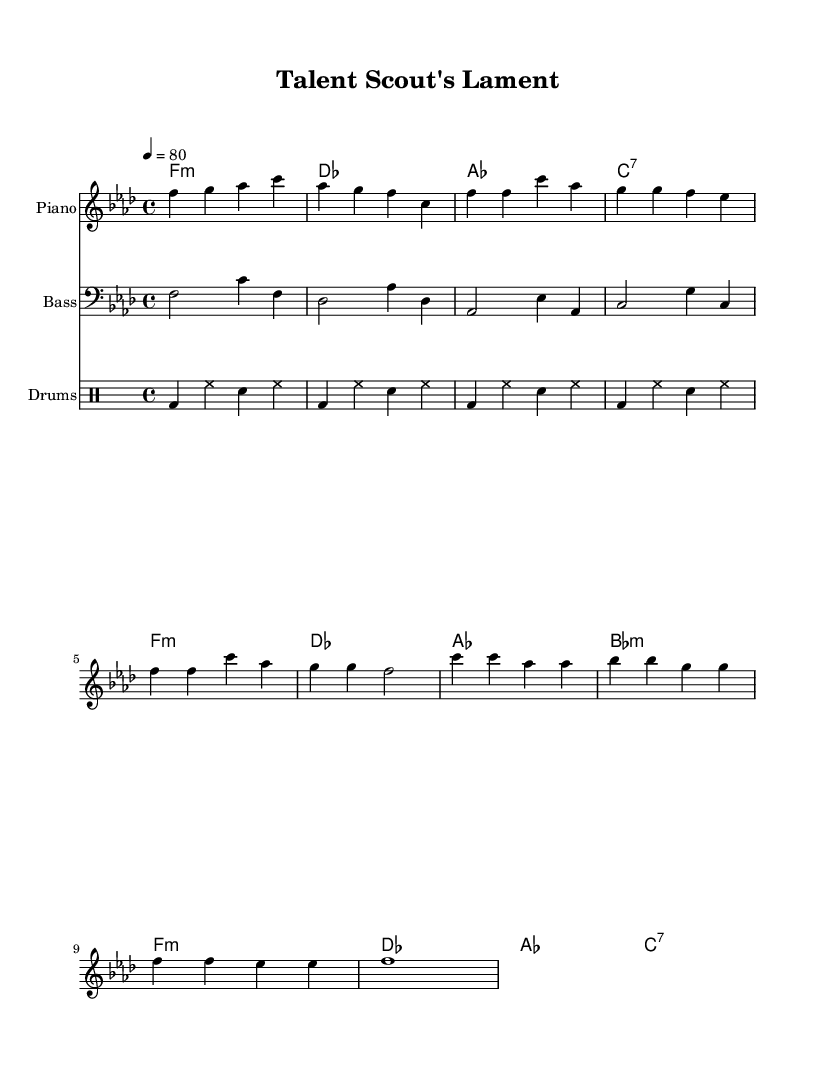What is the key signature of this music? The key signature is indicated at the beginning of the sheet music. In this piece, it shows one flat, indicating F minor.
Answer: F minor What is the time signature of this music? The time signature is found at the beginning of the music. It reads 4/4, which means there are four beats in each measure and the quarter note gets one beat.
Answer: 4/4 What is the tempo marking for this piece? The tempo marking is found above the staff. It states "4 = 80", meaning there are 80 quarter notes per minute.
Answer: 80 How many measures are in the chorus section? To find the number of measures in the chorus, you can count each measure in the chorus section indicated in the sheet music. There are a total of 4 measures in the chorus.
Answer: 4 What is the name of the song reflected in this sheet music? The title is located at the top of the sheet music, directly stating "Talent Scout's Lament".
Answer: Talent Scout's Lament What instrument is primarily featured for the melody? The instrument name is indicated above the staff where the melody is written, which shows "Piano".
Answer: Piano What type of drum pattern is used in this music? The drum pattern is indicated in the drum staff using a standard rhythmic notation for a hip-hop style, which relies on bass drum, hi-hats, and snare. Specifically, it features a repetitive pattern typical for this genre.
Answer: Hip-hop 